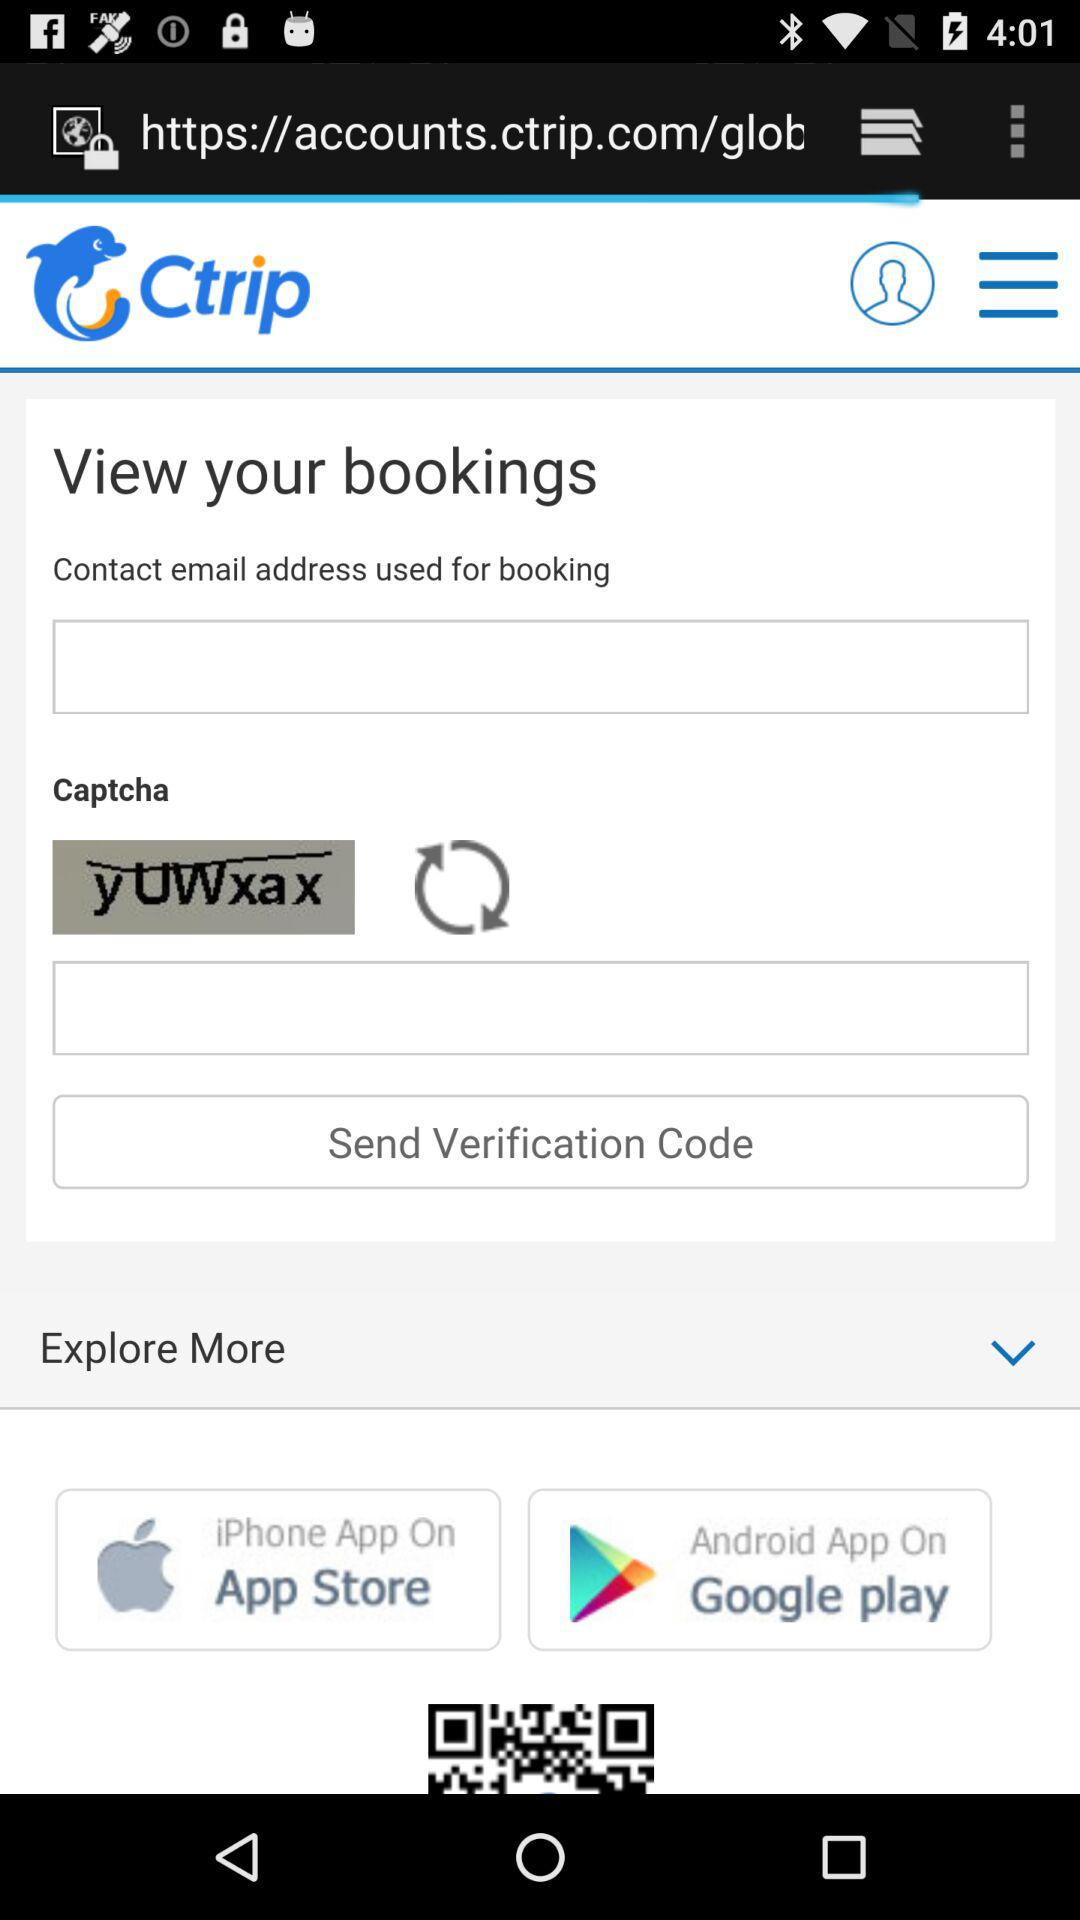What is a captcha? The captcha is "yUWxax". 